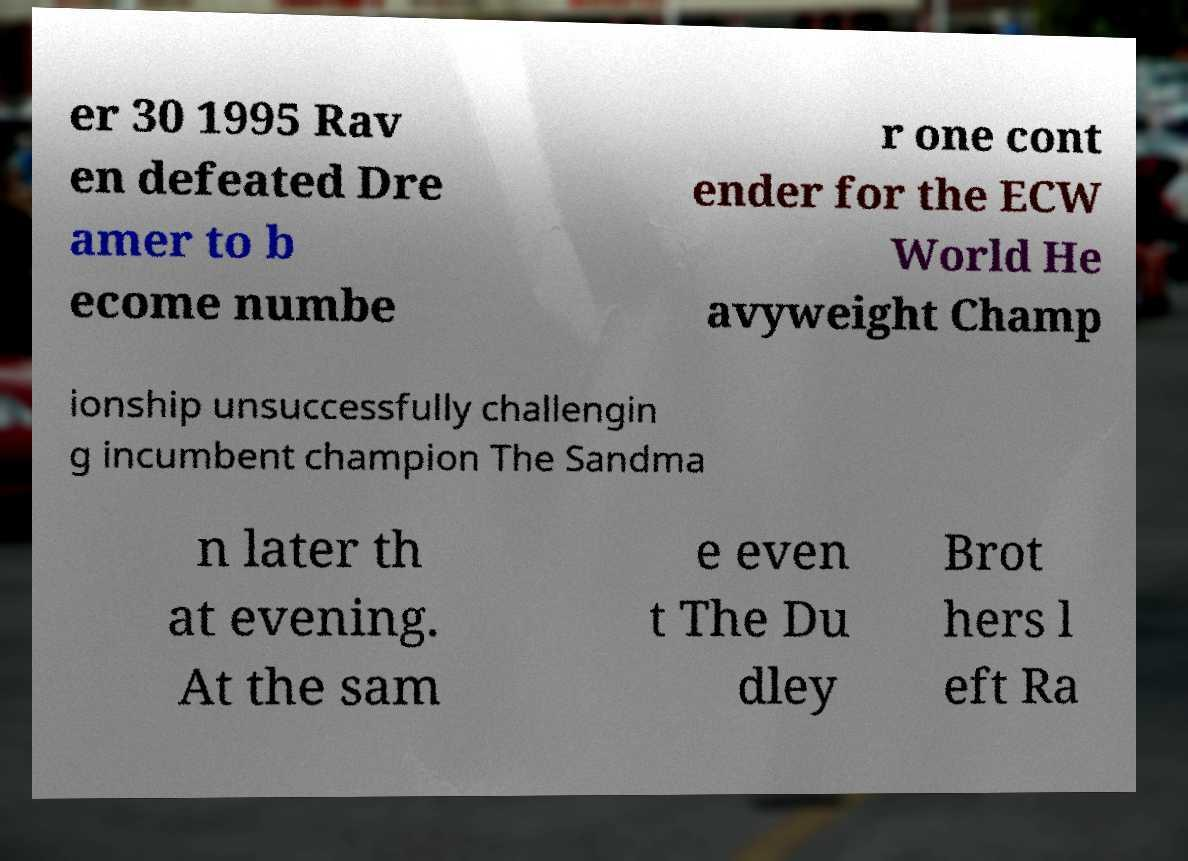Could you assist in decoding the text presented in this image and type it out clearly? er 30 1995 Rav en defeated Dre amer to b ecome numbe r one cont ender for the ECW World He avyweight Champ ionship unsuccessfully challengin g incumbent champion The Sandma n later th at evening. At the sam e even t The Du dley Brot hers l eft Ra 